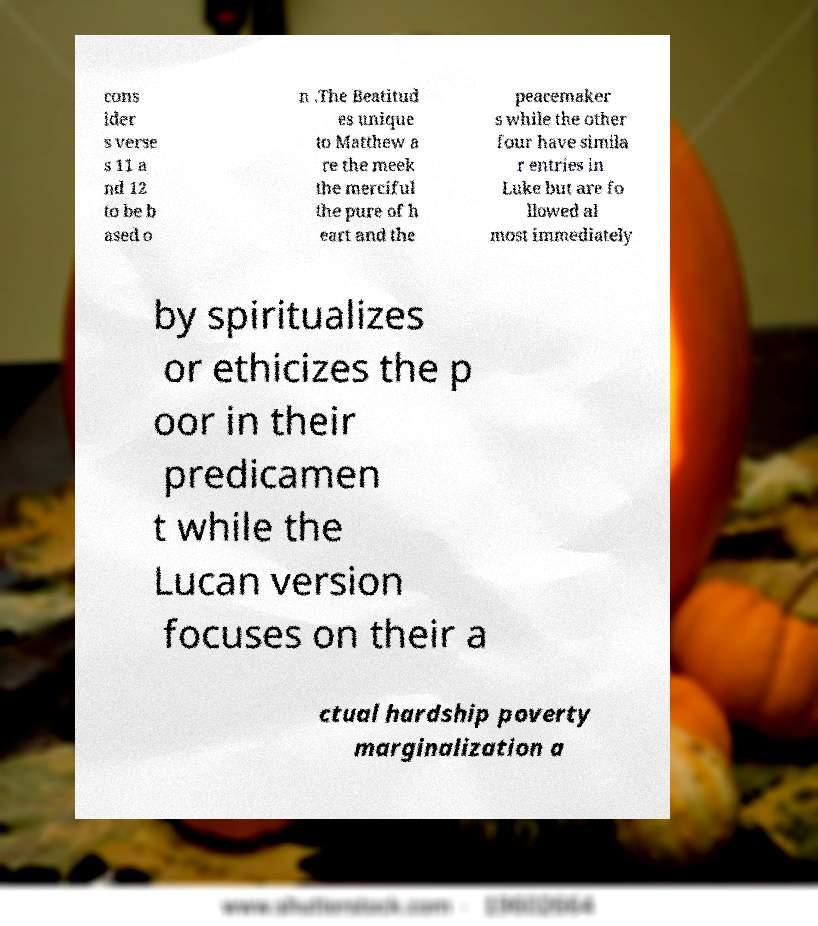For documentation purposes, I need the text within this image transcribed. Could you provide that? cons ider s verse s 11 a nd 12 to be b ased o n .The Beatitud es unique to Matthew a re the meek the merciful the pure of h eart and the peacemaker s while the other four have simila r entries in Luke but are fo llowed al most immediately by spiritualizes or ethicizes the p oor in their predicamen t while the Lucan version focuses on their a ctual hardship poverty marginalization a 